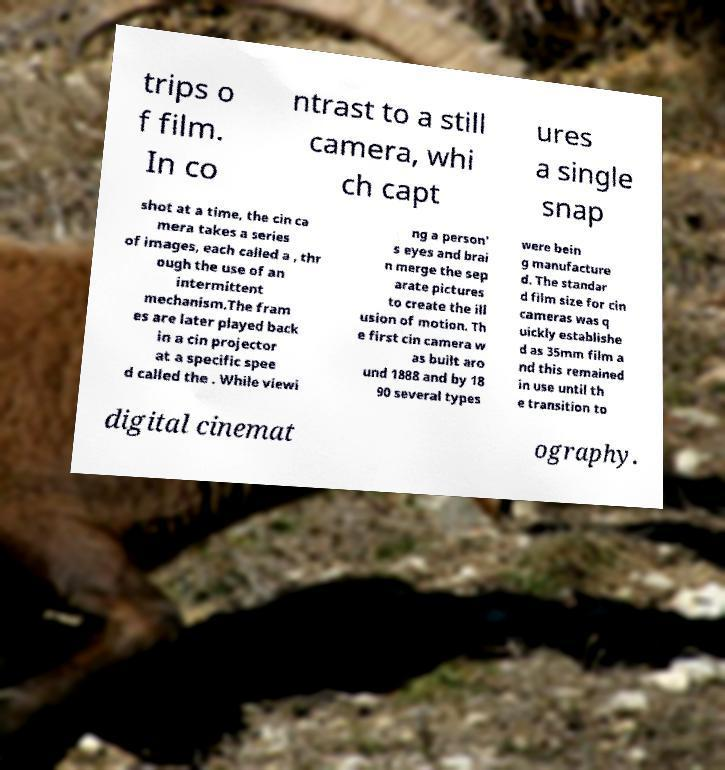Please read and relay the text visible in this image. What does it say? trips o f film. In co ntrast to a still camera, whi ch capt ures a single snap shot at a time, the cin ca mera takes a series of images, each called a , thr ough the use of an intermittent mechanism.The fram es are later played back in a cin projector at a specific spee d called the . While viewi ng a person' s eyes and brai n merge the sep arate pictures to create the ill usion of motion. Th e first cin camera w as built aro und 1888 and by 18 90 several types were bein g manufacture d. The standar d film size for cin cameras was q uickly establishe d as 35mm film a nd this remained in use until th e transition to digital cinemat ography. 